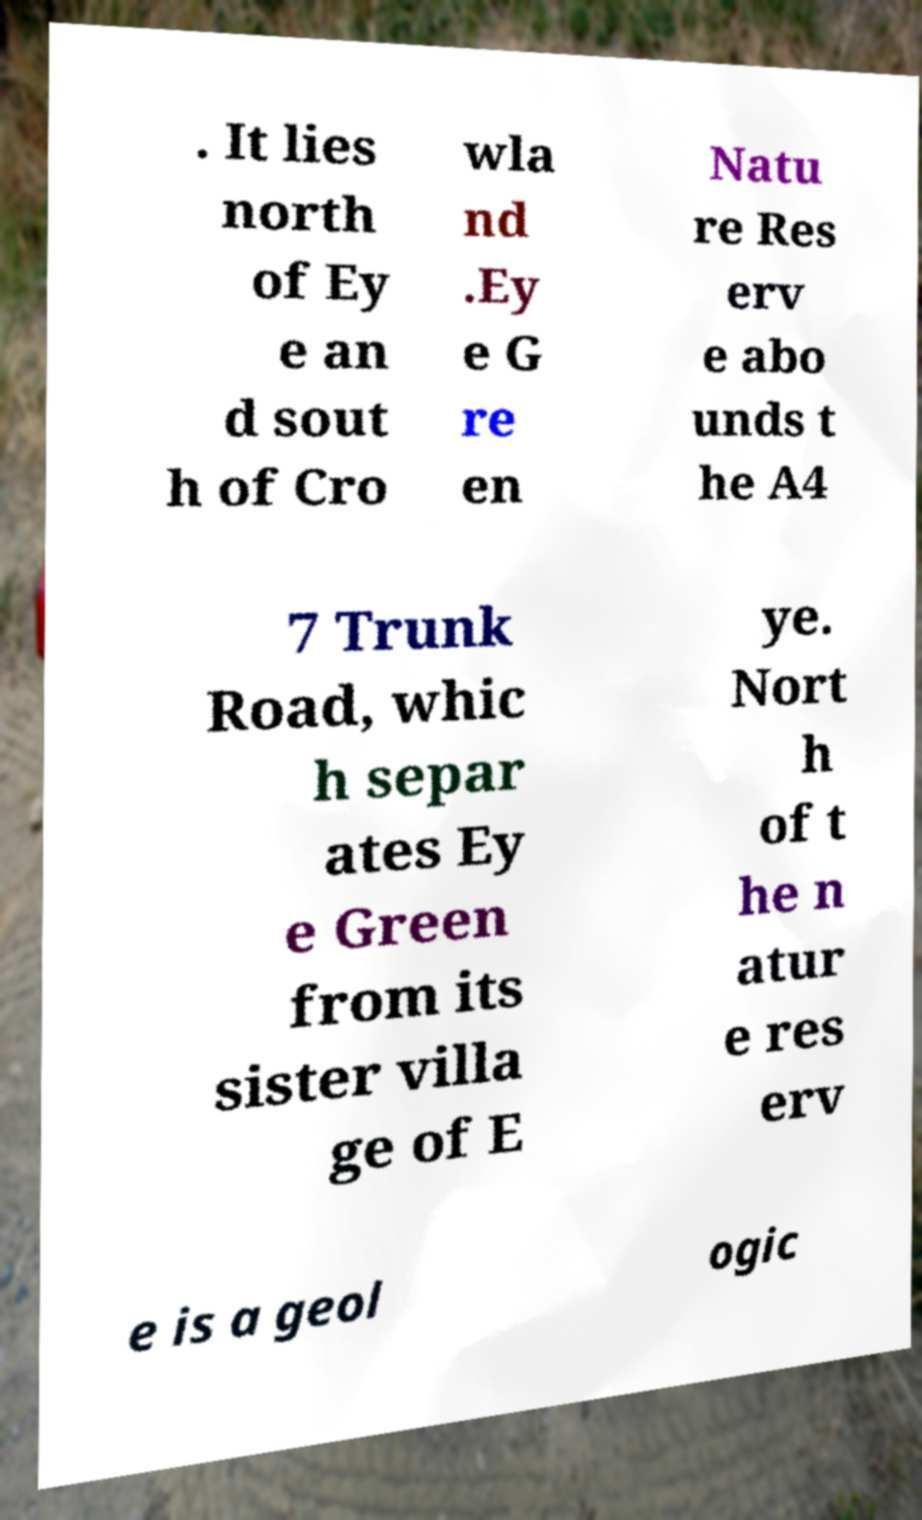Please identify and transcribe the text found in this image. . It lies north of Ey e an d sout h of Cro wla nd .Ey e G re en Natu re Res erv e abo unds t he A4 7 Trunk Road, whic h separ ates Ey e Green from its sister villa ge of E ye. Nort h of t he n atur e res erv e is a geol ogic 